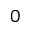<formula> <loc_0><loc_0><loc_500><loc_500>0</formula> 